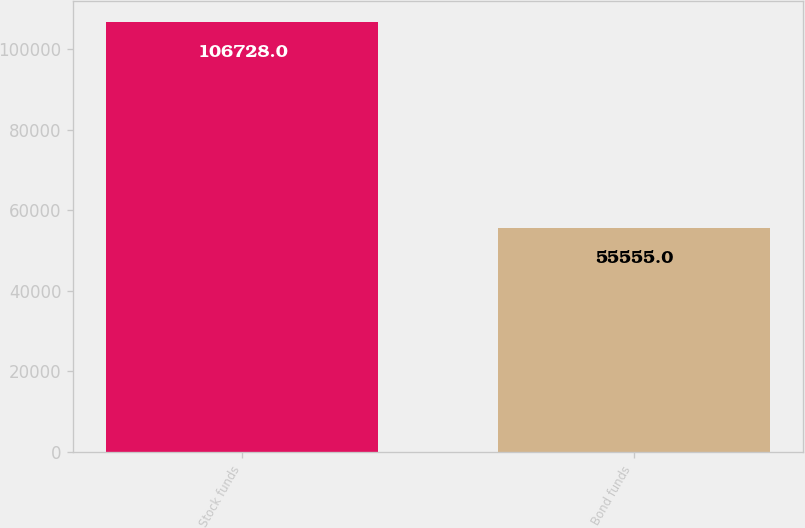Convert chart to OTSL. <chart><loc_0><loc_0><loc_500><loc_500><bar_chart><fcel>Stock funds<fcel>Bond funds<nl><fcel>106728<fcel>55555<nl></chart> 